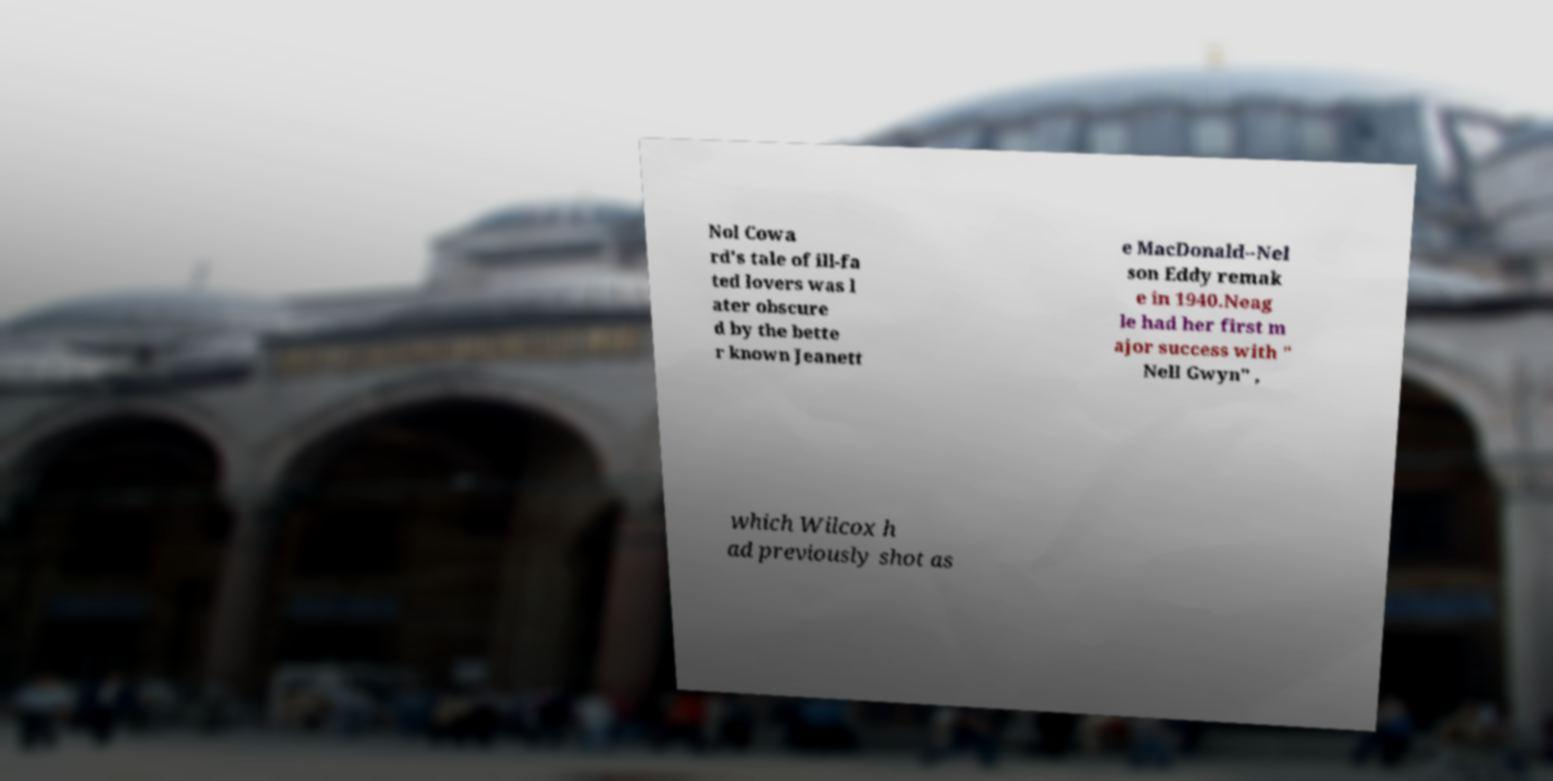Can you accurately transcribe the text from the provided image for me? Nol Cowa rd's tale of ill-fa ted lovers was l ater obscure d by the bette r known Jeanett e MacDonald–Nel son Eddy remak e in 1940.Neag le had her first m ajor success with " Nell Gwyn" , which Wilcox h ad previously shot as 